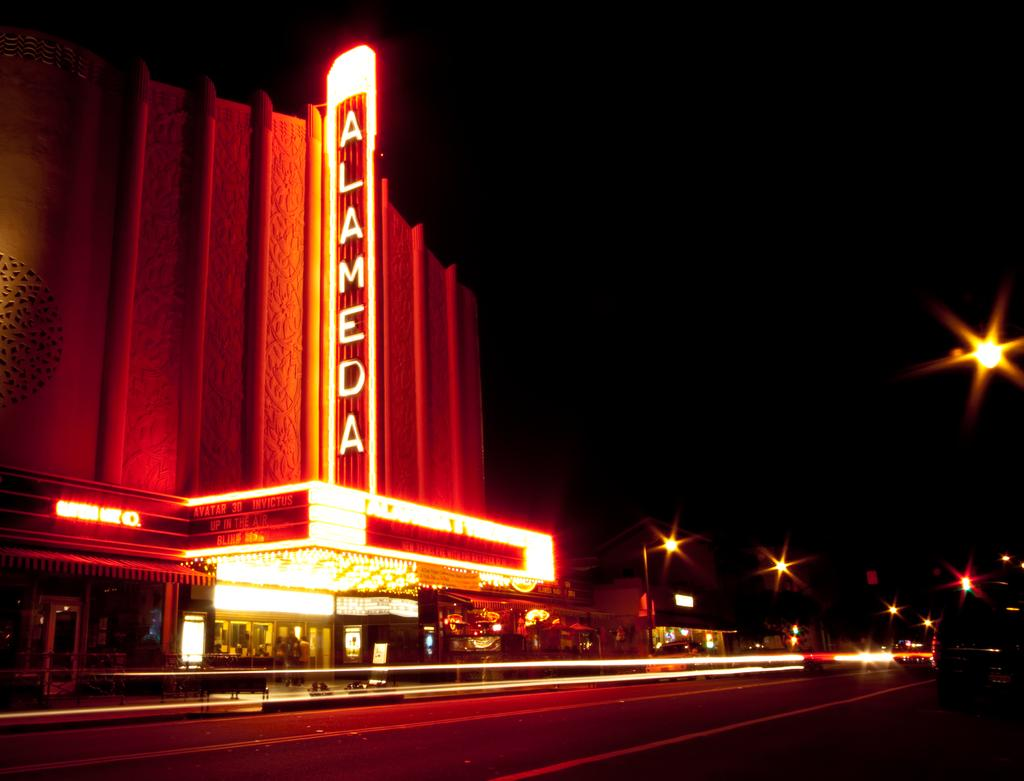What type of structures can be seen in the image? There are buildings in the image. What type of businesses might be present in the image? There are stores in the image. What can be seen illuminating the scene in the image? There are lights in the image. What colors are present in the lighting of the image? The lighting has orange and red colors. What is the color of the background in the image? The background of the image is black. What type of lock is used on the doors of the buildings in the image? There is no information about locks on the doors of the buildings in the image. What is the size of the stores in the image? There is no information about the size of the stores in the image. 